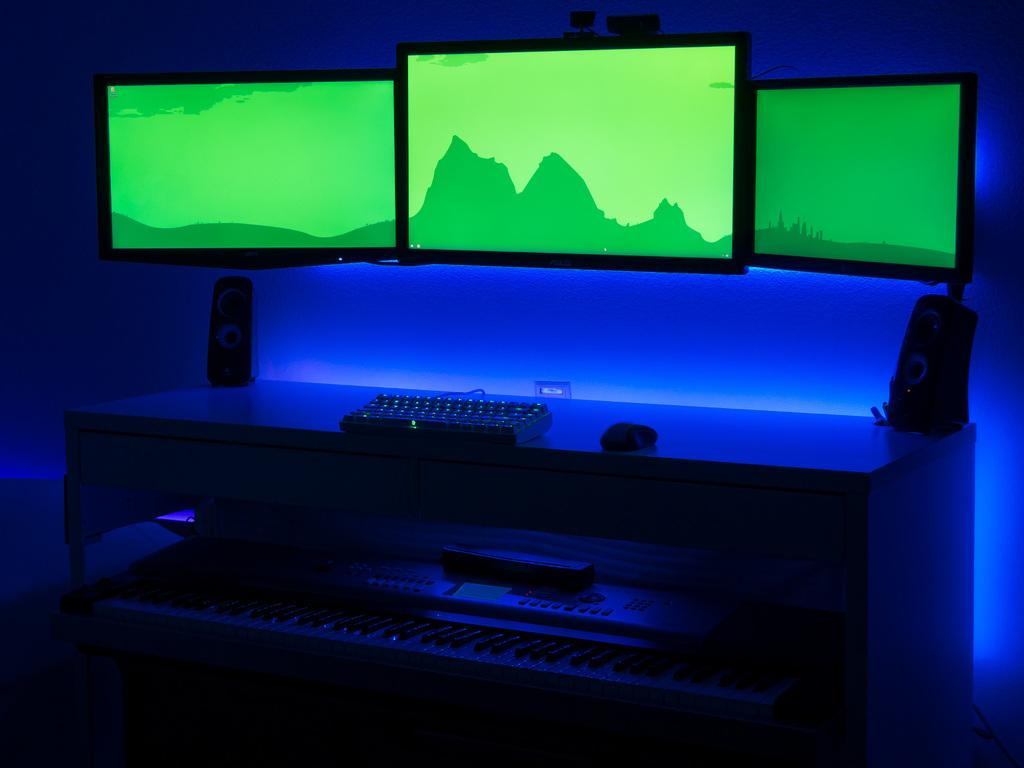How many monitor screens are visible in the image? There are three monitor screens in the image. What type of audio equipment is present in the image? There are woofers in the image. What piece of furniture is in the image? There is a table in the image. What input devices are on the table? A keyboard and a mouse are present on the table. What musical instrument can be seen in the image? There is a musical instrument in the image. What type of lace is draped over the musical instrument in the image? There is no lace present in the image; only the monitor screens, woofers, table, keyboard, mouse, and musical instrument are visible. How many dolls are sitting on the table in the image? There are no dolls present in the image. 